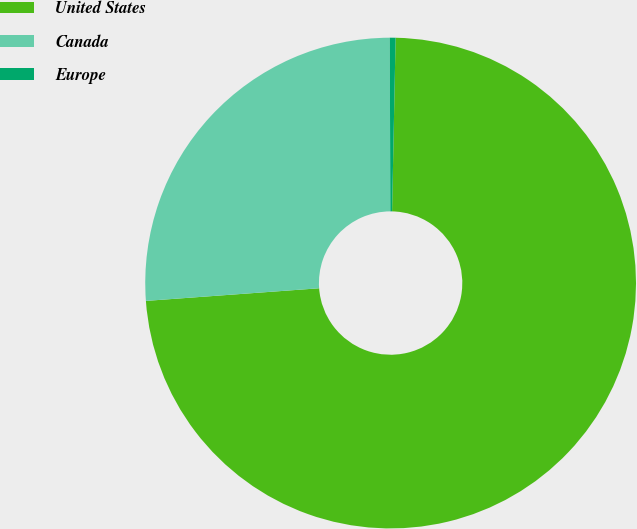Convert chart to OTSL. <chart><loc_0><loc_0><loc_500><loc_500><pie_chart><fcel>United States<fcel>Canada<fcel>Europe<nl><fcel>73.51%<fcel>26.1%<fcel>0.38%<nl></chart> 